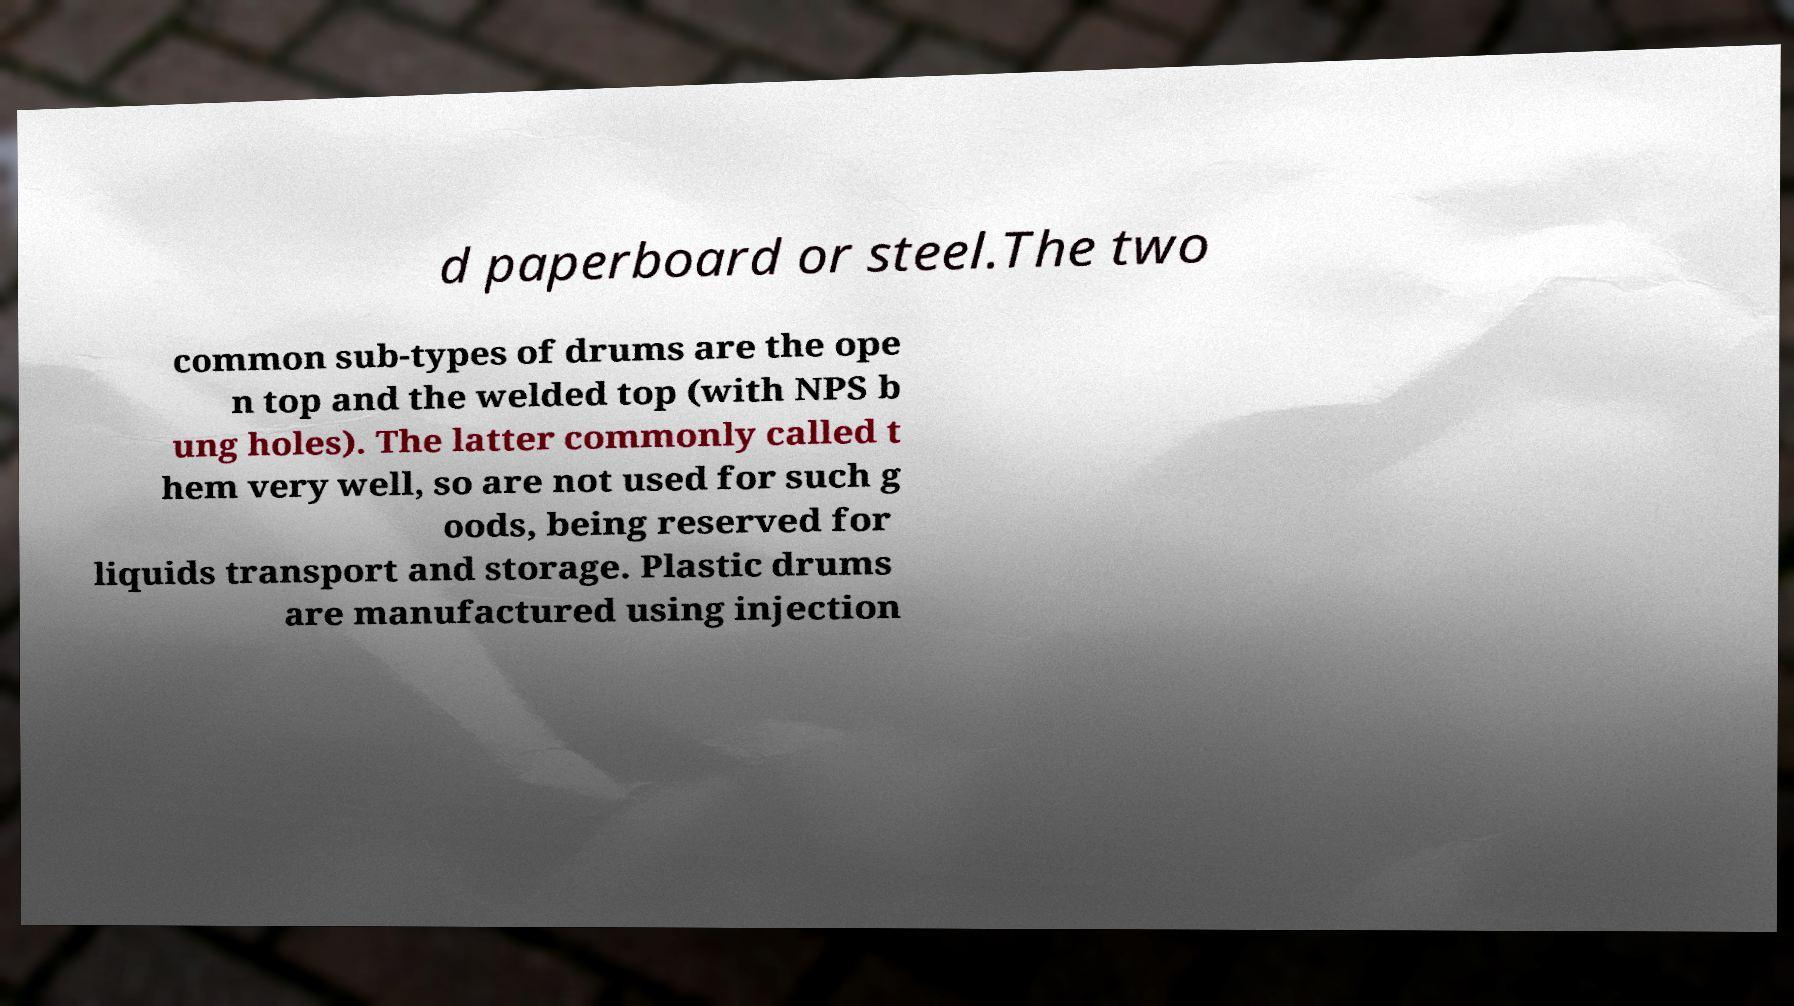I need the written content from this picture converted into text. Can you do that? d paperboard or steel.The two common sub-types of drums are the ope n top and the welded top (with NPS b ung holes). The latter commonly called t hem very well, so are not used for such g oods, being reserved for liquids transport and storage. Plastic drums are manufactured using injection 